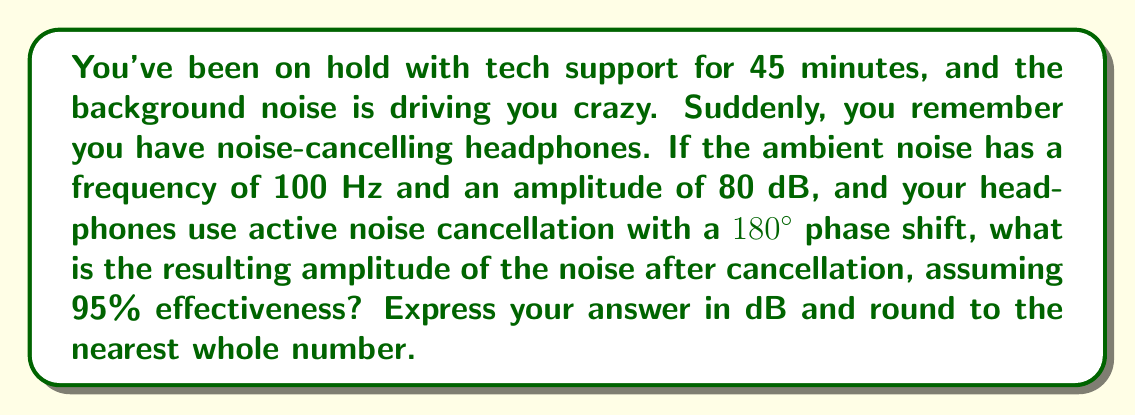Can you solve this math problem? Let's approach this step-by-step:

1) Active noise cancellation works by producing a sound wave with the same amplitude but opposite phase (180° shift) to the original noise.

2) The effectiveness of the noise cancellation is given as 95%. This means that 95% of the original noise amplitude is cancelled out.

3) The original noise amplitude is 80 dB. We need to calculate 5% of this (since 95% is cancelled):

   $$ 80 \text{ dB} \times 0.05 = 4 \text{ dB} $$

4) However, decibels are logarithmic units. We can't simply subtract 76 dB from 80 dB. We need to convert to linear scale, perform the calculation, and then convert back to dB.

5) The formula to convert from dB to linear scale is:

   $$ \text{Amplitude} = 10^{\frac{\text{dB}}{20}} $$

6) Converting 80 dB to linear scale:

   $$ 10^{\frac{80}{20}} = 10^4 = 10000 $$

7) 5% of this is:

   $$ 10000 \times 0.05 = 500 $$

8) Now we need to convert this back to dB using the formula:

   $$ \text{dB} = 20 \log_{10}(\text{Amplitude}) $$

9) Plugging in our value:

   $$ 20 \log_{10}(500) \approx 53.98 \text{ dB} $$

10) Rounding to the nearest whole number gives us 54 dB.
Answer: 54 dB 